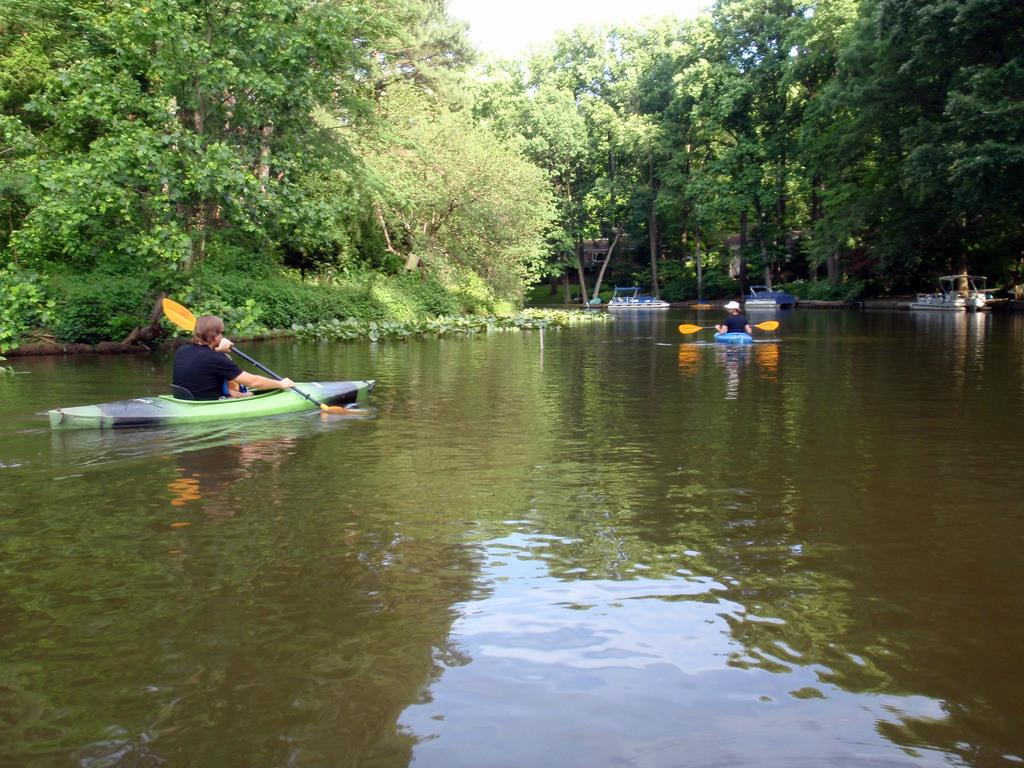What body of water is present in the image? There is a river in the image. What are the people in the image doing? People are boating on the river. What type of vegetation is near the river? There are trees around the river. What can be seen in the distance in the image? The sky is visible in the background of the image. How many ways can you touch the river in the image? You cannot touch the river in the image, as it is a two-dimensional representation. 